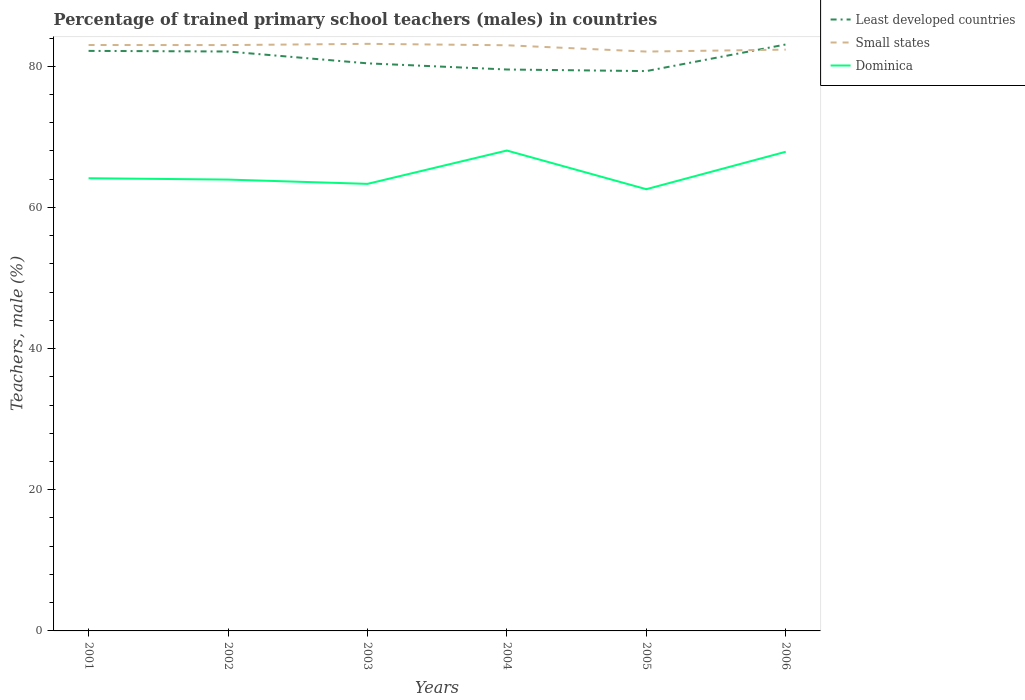Does the line corresponding to Dominica intersect with the line corresponding to Small states?
Provide a short and direct response. No. Is the number of lines equal to the number of legend labels?
Ensure brevity in your answer.  Yes. Across all years, what is the maximum percentage of trained primary school teachers (males) in Small states?
Keep it short and to the point. 82.08. In which year was the percentage of trained primary school teachers (males) in Dominica maximum?
Your answer should be very brief. 2005. What is the total percentage of trained primary school teachers (males) in Small states in the graph?
Your response must be concise. 0.92. What is the difference between the highest and the second highest percentage of trained primary school teachers (males) in Least developed countries?
Offer a terse response. 3.77. What is the difference between the highest and the lowest percentage of trained primary school teachers (males) in Least developed countries?
Give a very brief answer. 3. Is the percentage of trained primary school teachers (males) in Small states strictly greater than the percentage of trained primary school teachers (males) in Least developed countries over the years?
Give a very brief answer. No. What is the difference between two consecutive major ticks on the Y-axis?
Offer a terse response. 20. Where does the legend appear in the graph?
Provide a short and direct response. Top right. What is the title of the graph?
Your answer should be very brief. Percentage of trained primary school teachers (males) in countries. What is the label or title of the X-axis?
Make the answer very short. Years. What is the label or title of the Y-axis?
Give a very brief answer. Teachers, male (%). What is the Teachers, male (%) in Least developed countries in 2001?
Your response must be concise. 82.18. What is the Teachers, male (%) in Small states in 2001?
Your response must be concise. 83.01. What is the Teachers, male (%) in Dominica in 2001?
Your response must be concise. 64.14. What is the Teachers, male (%) of Least developed countries in 2002?
Your response must be concise. 82.09. What is the Teachers, male (%) of Small states in 2002?
Provide a short and direct response. 83. What is the Teachers, male (%) in Dominica in 2002?
Your response must be concise. 63.95. What is the Teachers, male (%) of Least developed countries in 2003?
Provide a short and direct response. 80.42. What is the Teachers, male (%) in Small states in 2003?
Provide a succinct answer. 83.18. What is the Teachers, male (%) of Dominica in 2003?
Your answer should be very brief. 63.34. What is the Teachers, male (%) in Least developed countries in 2004?
Keep it short and to the point. 79.54. What is the Teachers, male (%) of Small states in 2004?
Give a very brief answer. 82.98. What is the Teachers, male (%) in Dominica in 2004?
Your answer should be very brief. 68.07. What is the Teachers, male (%) of Least developed countries in 2005?
Give a very brief answer. 79.32. What is the Teachers, male (%) of Small states in 2005?
Provide a short and direct response. 82.08. What is the Teachers, male (%) in Dominica in 2005?
Your answer should be very brief. 62.59. What is the Teachers, male (%) of Least developed countries in 2006?
Offer a very short reply. 83.09. What is the Teachers, male (%) in Small states in 2006?
Offer a terse response. 82.36. What is the Teachers, male (%) in Dominica in 2006?
Make the answer very short. 67.89. Across all years, what is the maximum Teachers, male (%) of Least developed countries?
Offer a terse response. 83.09. Across all years, what is the maximum Teachers, male (%) in Small states?
Your response must be concise. 83.18. Across all years, what is the maximum Teachers, male (%) of Dominica?
Provide a succinct answer. 68.07. Across all years, what is the minimum Teachers, male (%) of Least developed countries?
Keep it short and to the point. 79.32. Across all years, what is the minimum Teachers, male (%) of Small states?
Your answer should be compact. 82.08. Across all years, what is the minimum Teachers, male (%) in Dominica?
Keep it short and to the point. 62.59. What is the total Teachers, male (%) of Least developed countries in the graph?
Ensure brevity in your answer.  486.65. What is the total Teachers, male (%) of Small states in the graph?
Make the answer very short. 496.62. What is the total Teachers, male (%) in Dominica in the graph?
Your answer should be compact. 389.97. What is the difference between the Teachers, male (%) in Least developed countries in 2001 and that in 2002?
Make the answer very short. 0.09. What is the difference between the Teachers, male (%) of Small states in 2001 and that in 2002?
Provide a succinct answer. 0.01. What is the difference between the Teachers, male (%) in Dominica in 2001 and that in 2002?
Your response must be concise. 0.19. What is the difference between the Teachers, male (%) of Least developed countries in 2001 and that in 2003?
Your answer should be very brief. 1.76. What is the difference between the Teachers, male (%) in Small states in 2001 and that in 2003?
Offer a terse response. -0.17. What is the difference between the Teachers, male (%) in Dominica in 2001 and that in 2003?
Make the answer very short. 0.8. What is the difference between the Teachers, male (%) of Least developed countries in 2001 and that in 2004?
Provide a succinct answer. 2.64. What is the difference between the Teachers, male (%) in Small states in 2001 and that in 2004?
Give a very brief answer. 0.04. What is the difference between the Teachers, male (%) of Dominica in 2001 and that in 2004?
Provide a succinct answer. -3.93. What is the difference between the Teachers, male (%) of Least developed countries in 2001 and that in 2005?
Ensure brevity in your answer.  2.86. What is the difference between the Teachers, male (%) in Small states in 2001 and that in 2005?
Your answer should be very brief. 0.93. What is the difference between the Teachers, male (%) in Dominica in 2001 and that in 2005?
Ensure brevity in your answer.  1.55. What is the difference between the Teachers, male (%) of Least developed countries in 2001 and that in 2006?
Your answer should be very brief. -0.91. What is the difference between the Teachers, male (%) in Small states in 2001 and that in 2006?
Give a very brief answer. 0.65. What is the difference between the Teachers, male (%) of Dominica in 2001 and that in 2006?
Offer a very short reply. -3.75. What is the difference between the Teachers, male (%) of Least developed countries in 2002 and that in 2003?
Offer a very short reply. 1.68. What is the difference between the Teachers, male (%) in Small states in 2002 and that in 2003?
Ensure brevity in your answer.  -0.17. What is the difference between the Teachers, male (%) in Dominica in 2002 and that in 2003?
Keep it short and to the point. 0.61. What is the difference between the Teachers, male (%) in Least developed countries in 2002 and that in 2004?
Offer a terse response. 2.55. What is the difference between the Teachers, male (%) of Small states in 2002 and that in 2004?
Your answer should be compact. 0.03. What is the difference between the Teachers, male (%) of Dominica in 2002 and that in 2004?
Your answer should be very brief. -4.12. What is the difference between the Teachers, male (%) of Least developed countries in 2002 and that in 2005?
Offer a terse response. 2.77. What is the difference between the Teachers, male (%) in Small states in 2002 and that in 2005?
Provide a short and direct response. 0.92. What is the difference between the Teachers, male (%) of Dominica in 2002 and that in 2005?
Your response must be concise. 1.36. What is the difference between the Teachers, male (%) of Least developed countries in 2002 and that in 2006?
Your answer should be very brief. -1. What is the difference between the Teachers, male (%) in Small states in 2002 and that in 2006?
Offer a terse response. 0.64. What is the difference between the Teachers, male (%) in Dominica in 2002 and that in 2006?
Your response must be concise. -3.94. What is the difference between the Teachers, male (%) of Least developed countries in 2003 and that in 2004?
Keep it short and to the point. 0.87. What is the difference between the Teachers, male (%) in Small states in 2003 and that in 2004?
Offer a terse response. 0.2. What is the difference between the Teachers, male (%) of Dominica in 2003 and that in 2004?
Your response must be concise. -4.72. What is the difference between the Teachers, male (%) of Least developed countries in 2003 and that in 2005?
Ensure brevity in your answer.  1.1. What is the difference between the Teachers, male (%) of Small states in 2003 and that in 2005?
Provide a succinct answer. 1.09. What is the difference between the Teachers, male (%) in Dominica in 2003 and that in 2005?
Offer a terse response. 0.76. What is the difference between the Teachers, male (%) of Least developed countries in 2003 and that in 2006?
Your answer should be very brief. -2.67. What is the difference between the Teachers, male (%) in Small states in 2003 and that in 2006?
Provide a short and direct response. 0.82. What is the difference between the Teachers, male (%) in Dominica in 2003 and that in 2006?
Give a very brief answer. -4.55. What is the difference between the Teachers, male (%) of Least developed countries in 2004 and that in 2005?
Offer a very short reply. 0.23. What is the difference between the Teachers, male (%) in Small states in 2004 and that in 2005?
Keep it short and to the point. 0.89. What is the difference between the Teachers, male (%) of Dominica in 2004 and that in 2005?
Provide a short and direct response. 5.48. What is the difference between the Teachers, male (%) in Least developed countries in 2004 and that in 2006?
Your answer should be very brief. -3.55. What is the difference between the Teachers, male (%) in Small states in 2004 and that in 2006?
Offer a terse response. 0.62. What is the difference between the Teachers, male (%) of Dominica in 2004 and that in 2006?
Give a very brief answer. 0.18. What is the difference between the Teachers, male (%) of Least developed countries in 2005 and that in 2006?
Provide a short and direct response. -3.77. What is the difference between the Teachers, male (%) in Small states in 2005 and that in 2006?
Your response must be concise. -0.28. What is the difference between the Teachers, male (%) in Dominica in 2005 and that in 2006?
Your answer should be very brief. -5.3. What is the difference between the Teachers, male (%) of Least developed countries in 2001 and the Teachers, male (%) of Small states in 2002?
Your response must be concise. -0.82. What is the difference between the Teachers, male (%) in Least developed countries in 2001 and the Teachers, male (%) in Dominica in 2002?
Your answer should be compact. 18.23. What is the difference between the Teachers, male (%) in Small states in 2001 and the Teachers, male (%) in Dominica in 2002?
Offer a terse response. 19.07. What is the difference between the Teachers, male (%) of Least developed countries in 2001 and the Teachers, male (%) of Small states in 2003?
Your response must be concise. -1. What is the difference between the Teachers, male (%) of Least developed countries in 2001 and the Teachers, male (%) of Dominica in 2003?
Provide a succinct answer. 18.84. What is the difference between the Teachers, male (%) in Small states in 2001 and the Teachers, male (%) in Dominica in 2003?
Offer a terse response. 19.67. What is the difference between the Teachers, male (%) of Least developed countries in 2001 and the Teachers, male (%) of Small states in 2004?
Your answer should be compact. -0.8. What is the difference between the Teachers, male (%) of Least developed countries in 2001 and the Teachers, male (%) of Dominica in 2004?
Ensure brevity in your answer.  14.12. What is the difference between the Teachers, male (%) in Small states in 2001 and the Teachers, male (%) in Dominica in 2004?
Provide a succinct answer. 14.95. What is the difference between the Teachers, male (%) of Least developed countries in 2001 and the Teachers, male (%) of Small states in 2005?
Provide a succinct answer. 0.1. What is the difference between the Teachers, male (%) of Least developed countries in 2001 and the Teachers, male (%) of Dominica in 2005?
Make the answer very short. 19.6. What is the difference between the Teachers, male (%) of Small states in 2001 and the Teachers, male (%) of Dominica in 2005?
Ensure brevity in your answer.  20.43. What is the difference between the Teachers, male (%) in Least developed countries in 2001 and the Teachers, male (%) in Small states in 2006?
Keep it short and to the point. -0.18. What is the difference between the Teachers, male (%) of Least developed countries in 2001 and the Teachers, male (%) of Dominica in 2006?
Ensure brevity in your answer.  14.29. What is the difference between the Teachers, male (%) in Small states in 2001 and the Teachers, male (%) in Dominica in 2006?
Your answer should be compact. 15.12. What is the difference between the Teachers, male (%) in Least developed countries in 2002 and the Teachers, male (%) in Small states in 2003?
Provide a short and direct response. -1.09. What is the difference between the Teachers, male (%) of Least developed countries in 2002 and the Teachers, male (%) of Dominica in 2003?
Your response must be concise. 18.75. What is the difference between the Teachers, male (%) in Small states in 2002 and the Teachers, male (%) in Dominica in 2003?
Provide a short and direct response. 19.66. What is the difference between the Teachers, male (%) of Least developed countries in 2002 and the Teachers, male (%) of Small states in 2004?
Give a very brief answer. -0.88. What is the difference between the Teachers, male (%) in Least developed countries in 2002 and the Teachers, male (%) in Dominica in 2004?
Your answer should be compact. 14.03. What is the difference between the Teachers, male (%) of Small states in 2002 and the Teachers, male (%) of Dominica in 2004?
Give a very brief answer. 14.94. What is the difference between the Teachers, male (%) in Least developed countries in 2002 and the Teachers, male (%) in Small states in 2005?
Offer a very short reply. 0.01. What is the difference between the Teachers, male (%) of Least developed countries in 2002 and the Teachers, male (%) of Dominica in 2005?
Provide a short and direct response. 19.51. What is the difference between the Teachers, male (%) of Small states in 2002 and the Teachers, male (%) of Dominica in 2005?
Your answer should be very brief. 20.42. What is the difference between the Teachers, male (%) in Least developed countries in 2002 and the Teachers, male (%) in Small states in 2006?
Your answer should be compact. -0.27. What is the difference between the Teachers, male (%) in Least developed countries in 2002 and the Teachers, male (%) in Dominica in 2006?
Provide a succinct answer. 14.2. What is the difference between the Teachers, male (%) in Small states in 2002 and the Teachers, male (%) in Dominica in 2006?
Offer a terse response. 15.11. What is the difference between the Teachers, male (%) of Least developed countries in 2003 and the Teachers, male (%) of Small states in 2004?
Ensure brevity in your answer.  -2.56. What is the difference between the Teachers, male (%) in Least developed countries in 2003 and the Teachers, male (%) in Dominica in 2004?
Keep it short and to the point. 12.35. What is the difference between the Teachers, male (%) in Small states in 2003 and the Teachers, male (%) in Dominica in 2004?
Provide a short and direct response. 15.11. What is the difference between the Teachers, male (%) of Least developed countries in 2003 and the Teachers, male (%) of Small states in 2005?
Give a very brief answer. -1.67. What is the difference between the Teachers, male (%) of Least developed countries in 2003 and the Teachers, male (%) of Dominica in 2005?
Provide a short and direct response. 17.83. What is the difference between the Teachers, male (%) of Small states in 2003 and the Teachers, male (%) of Dominica in 2005?
Your answer should be very brief. 20.59. What is the difference between the Teachers, male (%) in Least developed countries in 2003 and the Teachers, male (%) in Small states in 2006?
Keep it short and to the point. -1.94. What is the difference between the Teachers, male (%) in Least developed countries in 2003 and the Teachers, male (%) in Dominica in 2006?
Make the answer very short. 12.53. What is the difference between the Teachers, male (%) in Small states in 2003 and the Teachers, male (%) in Dominica in 2006?
Keep it short and to the point. 15.29. What is the difference between the Teachers, male (%) of Least developed countries in 2004 and the Teachers, male (%) of Small states in 2005?
Your response must be concise. -2.54. What is the difference between the Teachers, male (%) in Least developed countries in 2004 and the Teachers, male (%) in Dominica in 2005?
Provide a short and direct response. 16.96. What is the difference between the Teachers, male (%) of Small states in 2004 and the Teachers, male (%) of Dominica in 2005?
Offer a very short reply. 20.39. What is the difference between the Teachers, male (%) of Least developed countries in 2004 and the Teachers, male (%) of Small states in 2006?
Offer a terse response. -2.82. What is the difference between the Teachers, male (%) in Least developed countries in 2004 and the Teachers, male (%) in Dominica in 2006?
Offer a very short reply. 11.65. What is the difference between the Teachers, male (%) in Small states in 2004 and the Teachers, male (%) in Dominica in 2006?
Ensure brevity in your answer.  15.09. What is the difference between the Teachers, male (%) in Least developed countries in 2005 and the Teachers, male (%) in Small states in 2006?
Your answer should be compact. -3.04. What is the difference between the Teachers, male (%) of Least developed countries in 2005 and the Teachers, male (%) of Dominica in 2006?
Ensure brevity in your answer.  11.43. What is the difference between the Teachers, male (%) of Small states in 2005 and the Teachers, male (%) of Dominica in 2006?
Ensure brevity in your answer.  14.2. What is the average Teachers, male (%) of Least developed countries per year?
Keep it short and to the point. 81.11. What is the average Teachers, male (%) of Small states per year?
Provide a succinct answer. 82.77. What is the average Teachers, male (%) of Dominica per year?
Provide a succinct answer. 64.99. In the year 2001, what is the difference between the Teachers, male (%) of Least developed countries and Teachers, male (%) of Small states?
Your answer should be very brief. -0.83. In the year 2001, what is the difference between the Teachers, male (%) of Least developed countries and Teachers, male (%) of Dominica?
Your answer should be very brief. 18.04. In the year 2001, what is the difference between the Teachers, male (%) of Small states and Teachers, male (%) of Dominica?
Offer a terse response. 18.87. In the year 2002, what is the difference between the Teachers, male (%) of Least developed countries and Teachers, male (%) of Small states?
Provide a succinct answer. -0.91. In the year 2002, what is the difference between the Teachers, male (%) of Least developed countries and Teachers, male (%) of Dominica?
Offer a very short reply. 18.14. In the year 2002, what is the difference between the Teachers, male (%) of Small states and Teachers, male (%) of Dominica?
Ensure brevity in your answer.  19.06. In the year 2003, what is the difference between the Teachers, male (%) of Least developed countries and Teachers, male (%) of Small states?
Offer a terse response. -2.76. In the year 2003, what is the difference between the Teachers, male (%) of Least developed countries and Teachers, male (%) of Dominica?
Your answer should be compact. 17.08. In the year 2003, what is the difference between the Teachers, male (%) of Small states and Teachers, male (%) of Dominica?
Ensure brevity in your answer.  19.84. In the year 2004, what is the difference between the Teachers, male (%) in Least developed countries and Teachers, male (%) in Small states?
Offer a terse response. -3.43. In the year 2004, what is the difference between the Teachers, male (%) of Least developed countries and Teachers, male (%) of Dominica?
Your answer should be compact. 11.48. In the year 2004, what is the difference between the Teachers, male (%) of Small states and Teachers, male (%) of Dominica?
Your answer should be compact. 14.91. In the year 2005, what is the difference between the Teachers, male (%) in Least developed countries and Teachers, male (%) in Small states?
Keep it short and to the point. -2.77. In the year 2005, what is the difference between the Teachers, male (%) of Least developed countries and Teachers, male (%) of Dominica?
Provide a short and direct response. 16.73. In the year 2006, what is the difference between the Teachers, male (%) of Least developed countries and Teachers, male (%) of Small states?
Provide a succinct answer. 0.73. In the year 2006, what is the difference between the Teachers, male (%) of Small states and Teachers, male (%) of Dominica?
Ensure brevity in your answer.  14.47. What is the ratio of the Teachers, male (%) in Dominica in 2001 to that in 2002?
Provide a succinct answer. 1. What is the ratio of the Teachers, male (%) in Least developed countries in 2001 to that in 2003?
Ensure brevity in your answer.  1.02. What is the ratio of the Teachers, male (%) of Small states in 2001 to that in 2003?
Provide a succinct answer. 1. What is the ratio of the Teachers, male (%) in Dominica in 2001 to that in 2003?
Your answer should be very brief. 1.01. What is the ratio of the Teachers, male (%) in Least developed countries in 2001 to that in 2004?
Ensure brevity in your answer.  1.03. What is the ratio of the Teachers, male (%) in Small states in 2001 to that in 2004?
Provide a short and direct response. 1. What is the ratio of the Teachers, male (%) of Dominica in 2001 to that in 2004?
Provide a short and direct response. 0.94. What is the ratio of the Teachers, male (%) of Least developed countries in 2001 to that in 2005?
Your answer should be compact. 1.04. What is the ratio of the Teachers, male (%) in Small states in 2001 to that in 2005?
Keep it short and to the point. 1.01. What is the ratio of the Teachers, male (%) in Dominica in 2001 to that in 2005?
Ensure brevity in your answer.  1.02. What is the ratio of the Teachers, male (%) in Least developed countries in 2001 to that in 2006?
Your answer should be very brief. 0.99. What is the ratio of the Teachers, male (%) of Small states in 2001 to that in 2006?
Keep it short and to the point. 1.01. What is the ratio of the Teachers, male (%) in Dominica in 2001 to that in 2006?
Your answer should be compact. 0.94. What is the ratio of the Teachers, male (%) in Least developed countries in 2002 to that in 2003?
Your response must be concise. 1.02. What is the ratio of the Teachers, male (%) in Dominica in 2002 to that in 2003?
Make the answer very short. 1.01. What is the ratio of the Teachers, male (%) of Least developed countries in 2002 to that in 2004?
Ensure brevity in your answer.  1.03. What is the ratio of the Teachers, male (%) of Dominica in 2002 to that in 2004?
Offer a terse response. 0.94. What is the ratio of the Teachers, male (%) of Least developed countries in 2002 to that in 2005?
Give a very brief answer. 1.03. What is the ratio of the Teachers, male (%) in Small states in 2002 to that in 2005?
Provide a short and direct response. 1.01. What is the ratio of the Teachers, male (%) of Dominica in 2002 to that in 2005?
Your answer should be very brief. 1.02. What is the ratio of the Teachers, male (%) of Least developed countries in 2002 to that in 2006?
Your response must be concise. 0.99. What is the ratio of the Teachers, male (%) in Small states in 2002 to that in 2006?
Make the answer very short. 1.01. What is the ratio of the Teachers, male (%) in Dominica in 2002 to that in 2006?
Ensure brevity in your answer.  0.94. What is the ratio of the Teachers, male (%) in Small states in 2003 to that in 2004?
Give a very brief answer. 1. What is the ratio of the Teachers, male (%) of Dominica in 2003 to that in 2004?
Offer a very short reply. 0.93. What is the ratio of the Teachers, male (%) in Least developed countries in 2003 to that in 2005?
Offer a very short reply. 1.01. What is the ratio of the Teachers, male (%) of Small states in 2003 to that in 2005?
Provide a short and direct response. 1.01. What is the ratio of the Teachers, male (%) of Dominica in 2003 to that in 2005?
Your answer should be compact. 1.01. What is the ratio of the Teachers, male (%) in Least developed countries in 2003 to that in 2006?
Give a very brief answer. 0.97. What is the ratio of the Teachers, male (%) of Small states in 2003 to that in 2006?
Offer a very short reply. 1.01. What is the ratio of the Teachers, male (%) of Dominica in 2003 to that in 2006?
Offer a very short reply. 0.93. What is the ratio of the Teachers, male (%) in Least developed countries in 2004 to that in 2005?
Ensure brevity in your answer.  1. What is the ratio of the Teachers, male (%) of Small states in 2004 to that in 2005?
Offer a terse response. 1.01. What is the ratio of the Teachers, male (%) of Dominica in 2004 to that in 2005?
Provide a short and direct response. 1.09. What is the ratio of the Teachers, male (%) of Least developed countries in 2004 to that in 2006?
Make the answer very short. 0.96. What is the ratio of the Teachers, male (%) in Small states in 2004 to that in 2006?
Make the answer very short. 1.01. What is the ratio of the Teachers, male (%) of Least developed countries in 2005 to that in 2006?
Offer a very short reply. 0.95. What is the ratio of the Teachers, male (%) of Dominica in 2005 to that in 2006?
Make the answer very short. 0.92. What is the difference between the highest and the second highest Teachers, male (%) in Least developed countries?
Offer a terse response. 0.91. What is the difference between the highest and the second highest Teachers, male (%) of Small states?
Make the answer very short. 0.17. What is the difference between the highest and the second highest Teachers, male (%) of Dominica?
Keep it short and to the point. 0.18. What is the difference between the highest and the lowest Teachers, male (%) of Least developed countries?
Offer a terse response. 3.77. What is the difference between the highest and the lowest Teachers, male (%) of Small states?
Ensure brevity in your answer.  1.09. What is the difference between the highest and the lowest Teachers, male (%) of Dominica?
Your answer should be very brief. 5.48. 